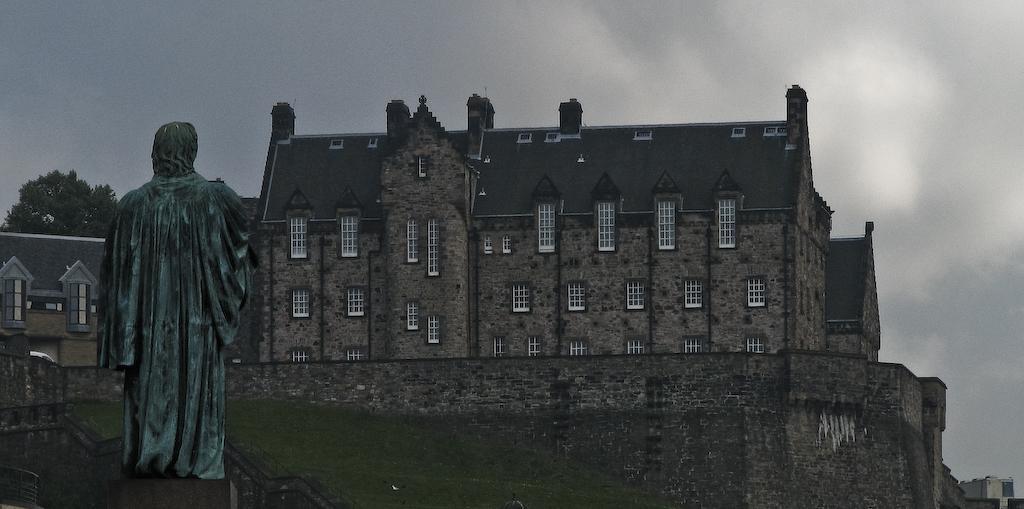Please provide a concise description of this image. This picture is clicked outside. On the left there is a sculpture of a person standing. In the center we can see the green grass, railing and we can see the buildings. In the background we can see the sky. On the left we can see the tree. 